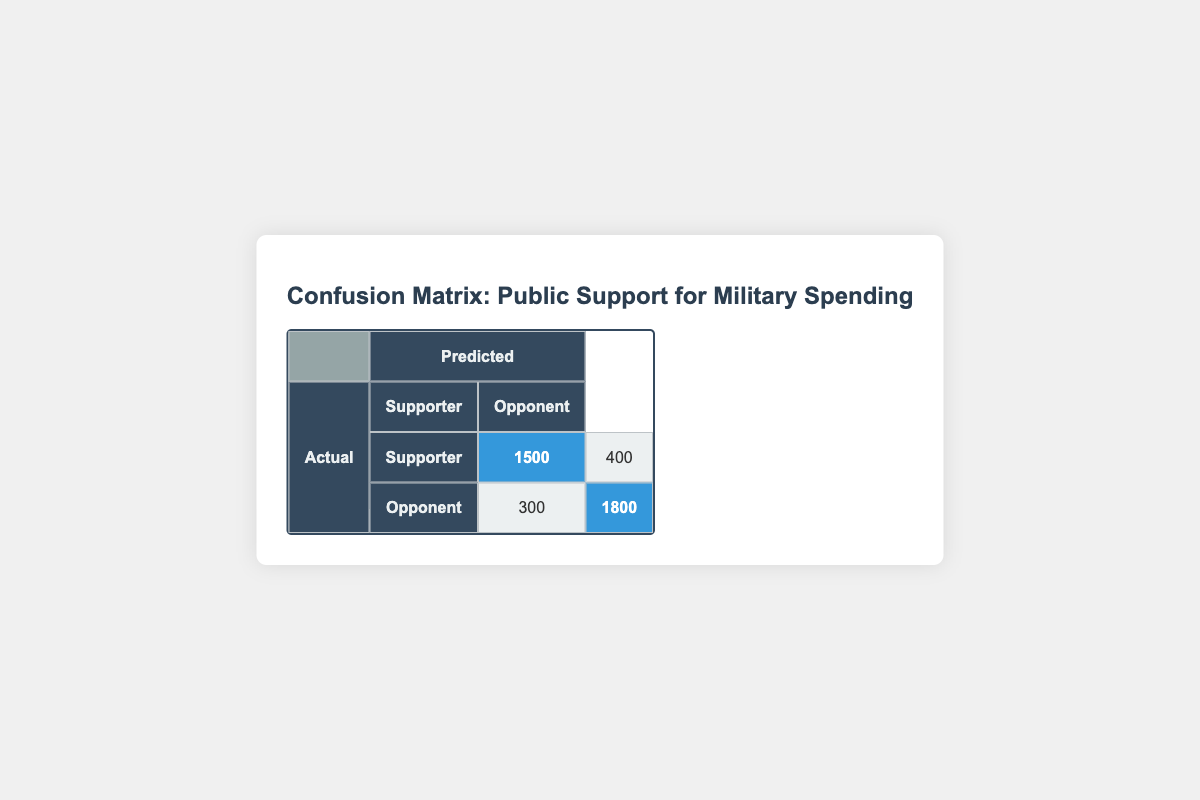What is the total number of supporters identified in the survey? The table shows that there are 1500 correctly identified supporters (actual Supporters predicted as Supporters) and 400 misidentified supporters (actual Supporters predicted as Opponents). Adding these together gives 1500 + 400 = 1900.
Answer: 1900 How many opponents were correctly identified in the survey? According to the table, there are 1800 correctly identified opponents (actual Opponents predicted as Opponents). Therefore, the count is directly available in the table.
Answer: 1800 What is the total number of respondents in the survey? To find the total respondents, we need to sum all values in the matrix: 1500 (correct Supporters) + 300 (incorrectly predicted Supporters) + 400 (incorrectly predicted Opponents) + 1800 (correct Opponents) = 3000.
Answer: 3000 Are there more supporters or opponents in the survey? The table shows that there are 1900 supporters (1500 + 400) and 2100 opponents (300 + 1800). Since 2100 > 1900, there are more opponents.
Answer: No What is the proportion of correctly identified supporters to incorrectly identified supporters? The correctly identified supporters count is 1500, and the incorrectly identified supporters count is 400. To find the proportion, we calculate 1500 / 400 = 3.75. Thus, the proportion is 3.75.
Answer: 3.75 What percentage of the actual supporters were correctly identified? There are 1900 actual supporters (1500 correct + 400 incorrect). The correctly identified supporters are 1500. To find the percentage, divide 1500 by 1900 and multiply by 100: (1500 / 1900) * 100 = approximately 78.95%.
Answer: 78.95% How many total misclassifications occurred in the survey? Misclassifications include the incorrect identification of supporters and opponents. This totals 300 (Supporters predicted as Opponents) + 400 (Opponents predicted as Supporters) = 700 misclassifications.
Answer: 700 If the survey had 1000 more respondents evenly distributed between supporters and opponents, how would that affect the total numbers? Adding 1000 respondents evenly changes the model to 500 additional Supporters and 500 additional Opponents. The new totals would be 1900 + 500 = 2400 (Supporters) and 2100 + 500 = 2600 (Opponents). This means Supporters would increase to 2400 and Opponents to 2600.
Answer: Supporters: 2400, Opponents: 2600 